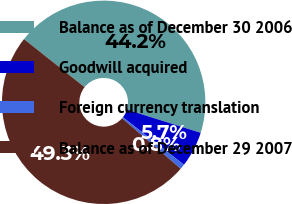<chart> <loc_0><loc_0><loc_500><loc_500><pie_chart><fcel>Balance as of December 30 2006<fcel>Goodwill acquired<fcel>Foreign currency translation<fcel>Balance as of December 29 2007<nl><fcel>44.17%<fcel>5.67%<fcel>0.81%<fcel>49.35%<nl></chart> 